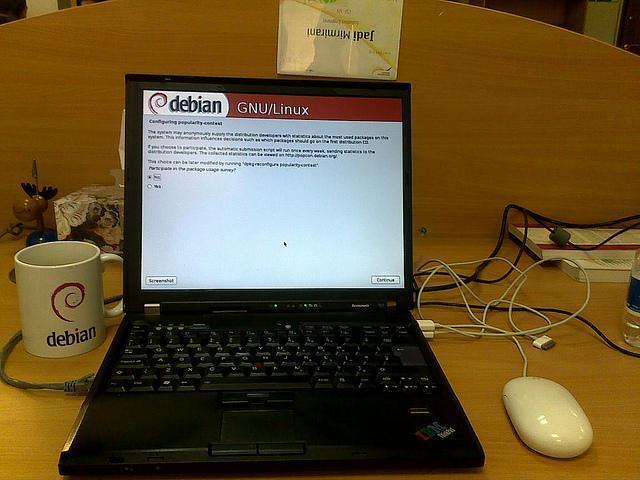How many keyboards are in the picture?
Give a very brief answer. 1. How many books are in the picture?
Give a very brief answer. 2. 